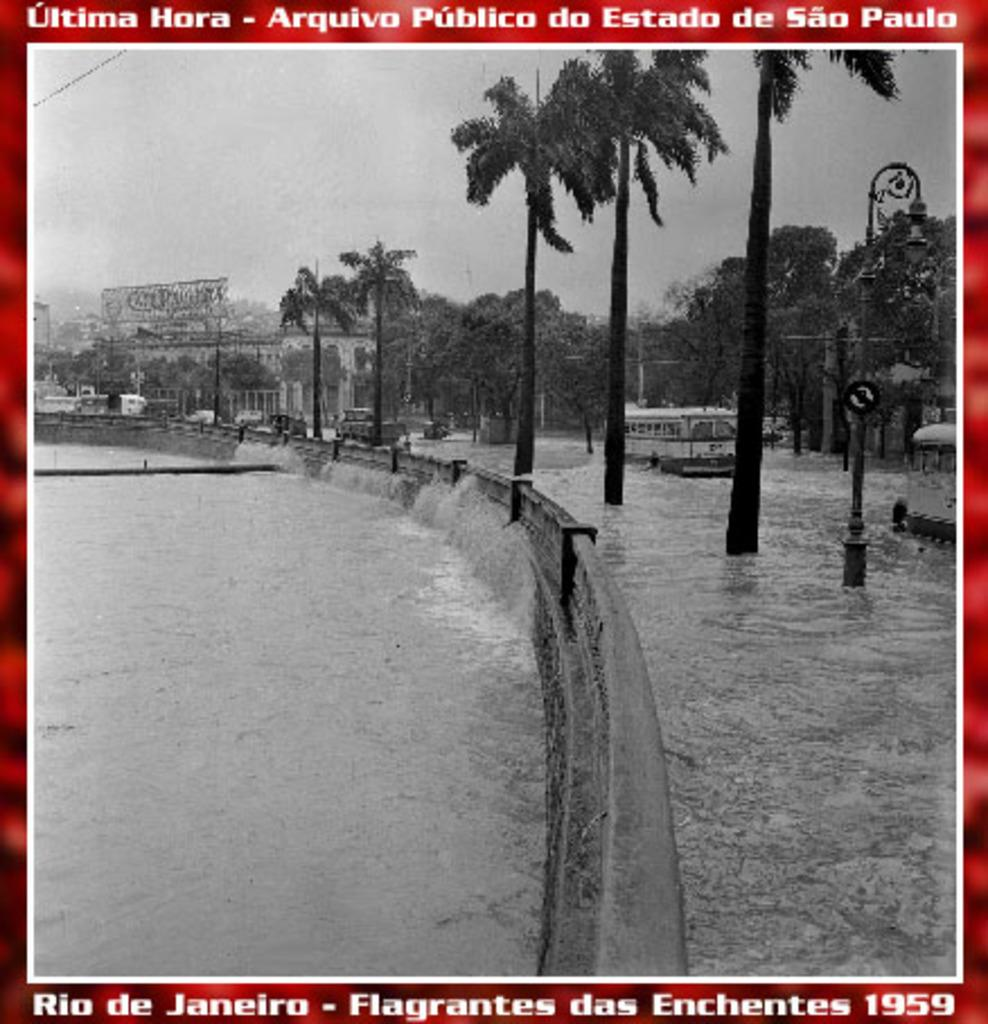What is depicted on the poster in the image? The poster contains vehicles, water, trees, poles, light, buildings, and a board. What other elements are present in the background of the poster? The poster contains trees, poles, light, buildings, and a board. What is visible in the background of the image? The sky is visible in the background of the image. Are there any circles visible on the poster? There is no mention of circles in the facts provided, so we cannot determine if there are any circles on the poster. Is there a farm depicted on the poster? There is no mention of a farm in the facts provided, so we cannot determine if there is a farm on the poster. 